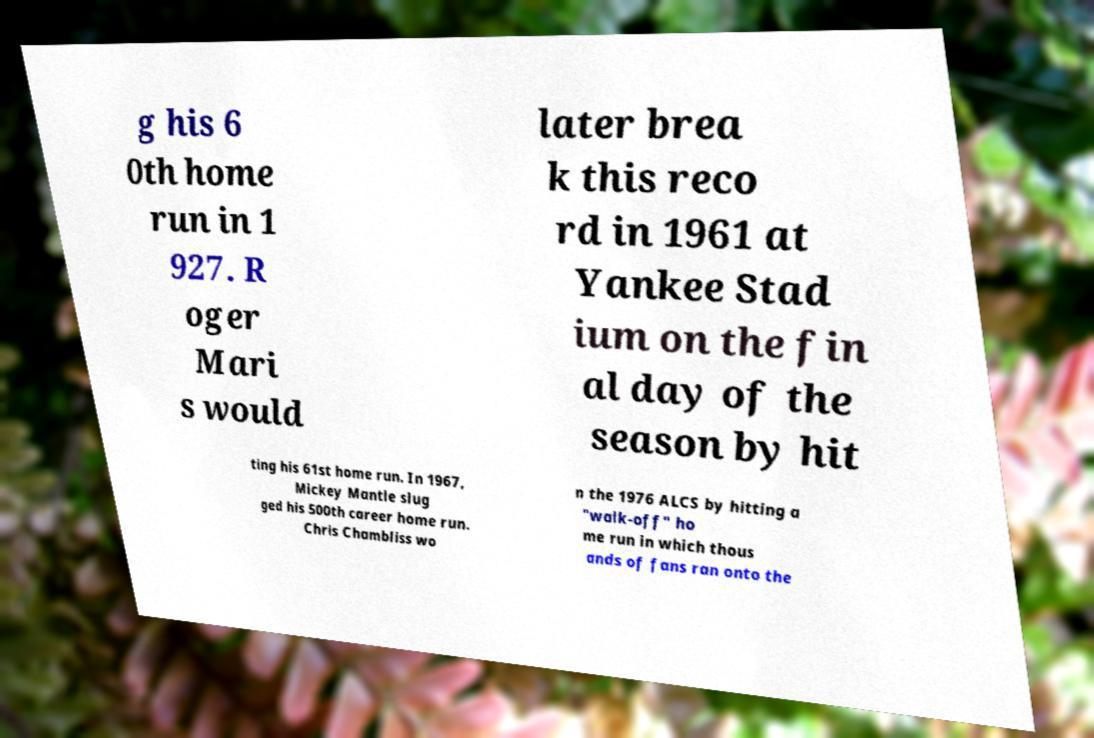Could you extract and type out the text from this image? g his 6 0th home run in 1 927. R oger Mari s would later brea k this reco rd in 1961 at Yankee Stad ium on the fin al day of the season by hit ting his 61st home run. In 1967, Mickey Mantle slug ged his 500th career home run. Chris Chambliss wo n the 1976 ALCS by hitting a "walk-off" ho me run in which thous ands of fans ran onto the 